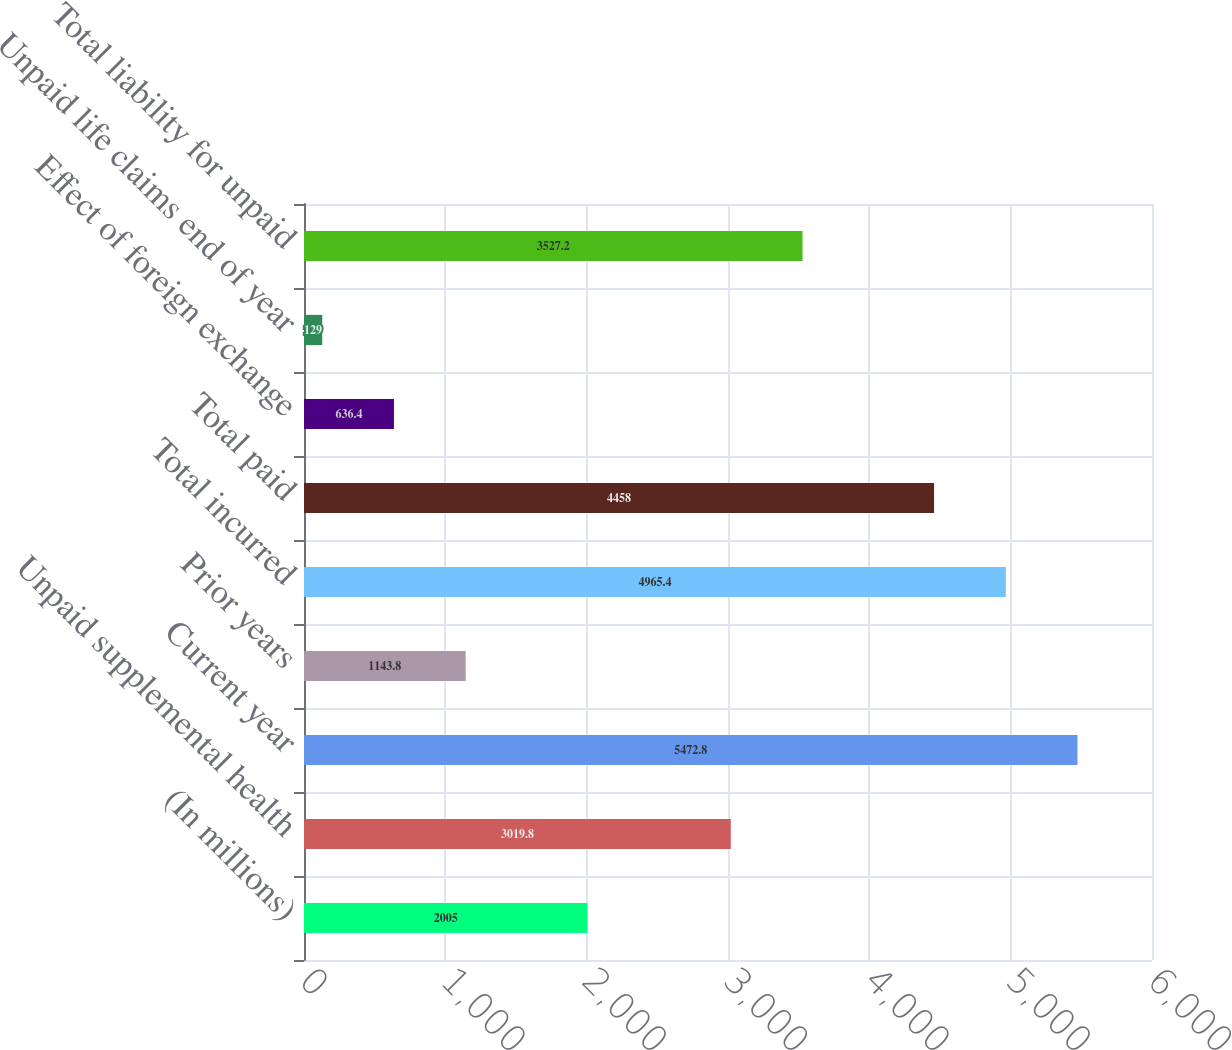<chart> <loc_0><loc_0><loc_500><loc_500><bar_chart><fcel>(In millions)<fcel>Unpaid supplemental health<fcel>Current year<fcel>Prior years<fcel>Total incurred<fcel>Total paid<fcel>Effect of foreign exchange<fcel>Unpaid life claims end of year<fcel>Total liability for unpaid<nl><fcel>2005<fcel>3019.8<fcel>5472.8<fcel>1143.8<fcel>4965.4<fcel>4458<fcel>636.4<fcel>129<fcel>3527.2<nl></chart> 